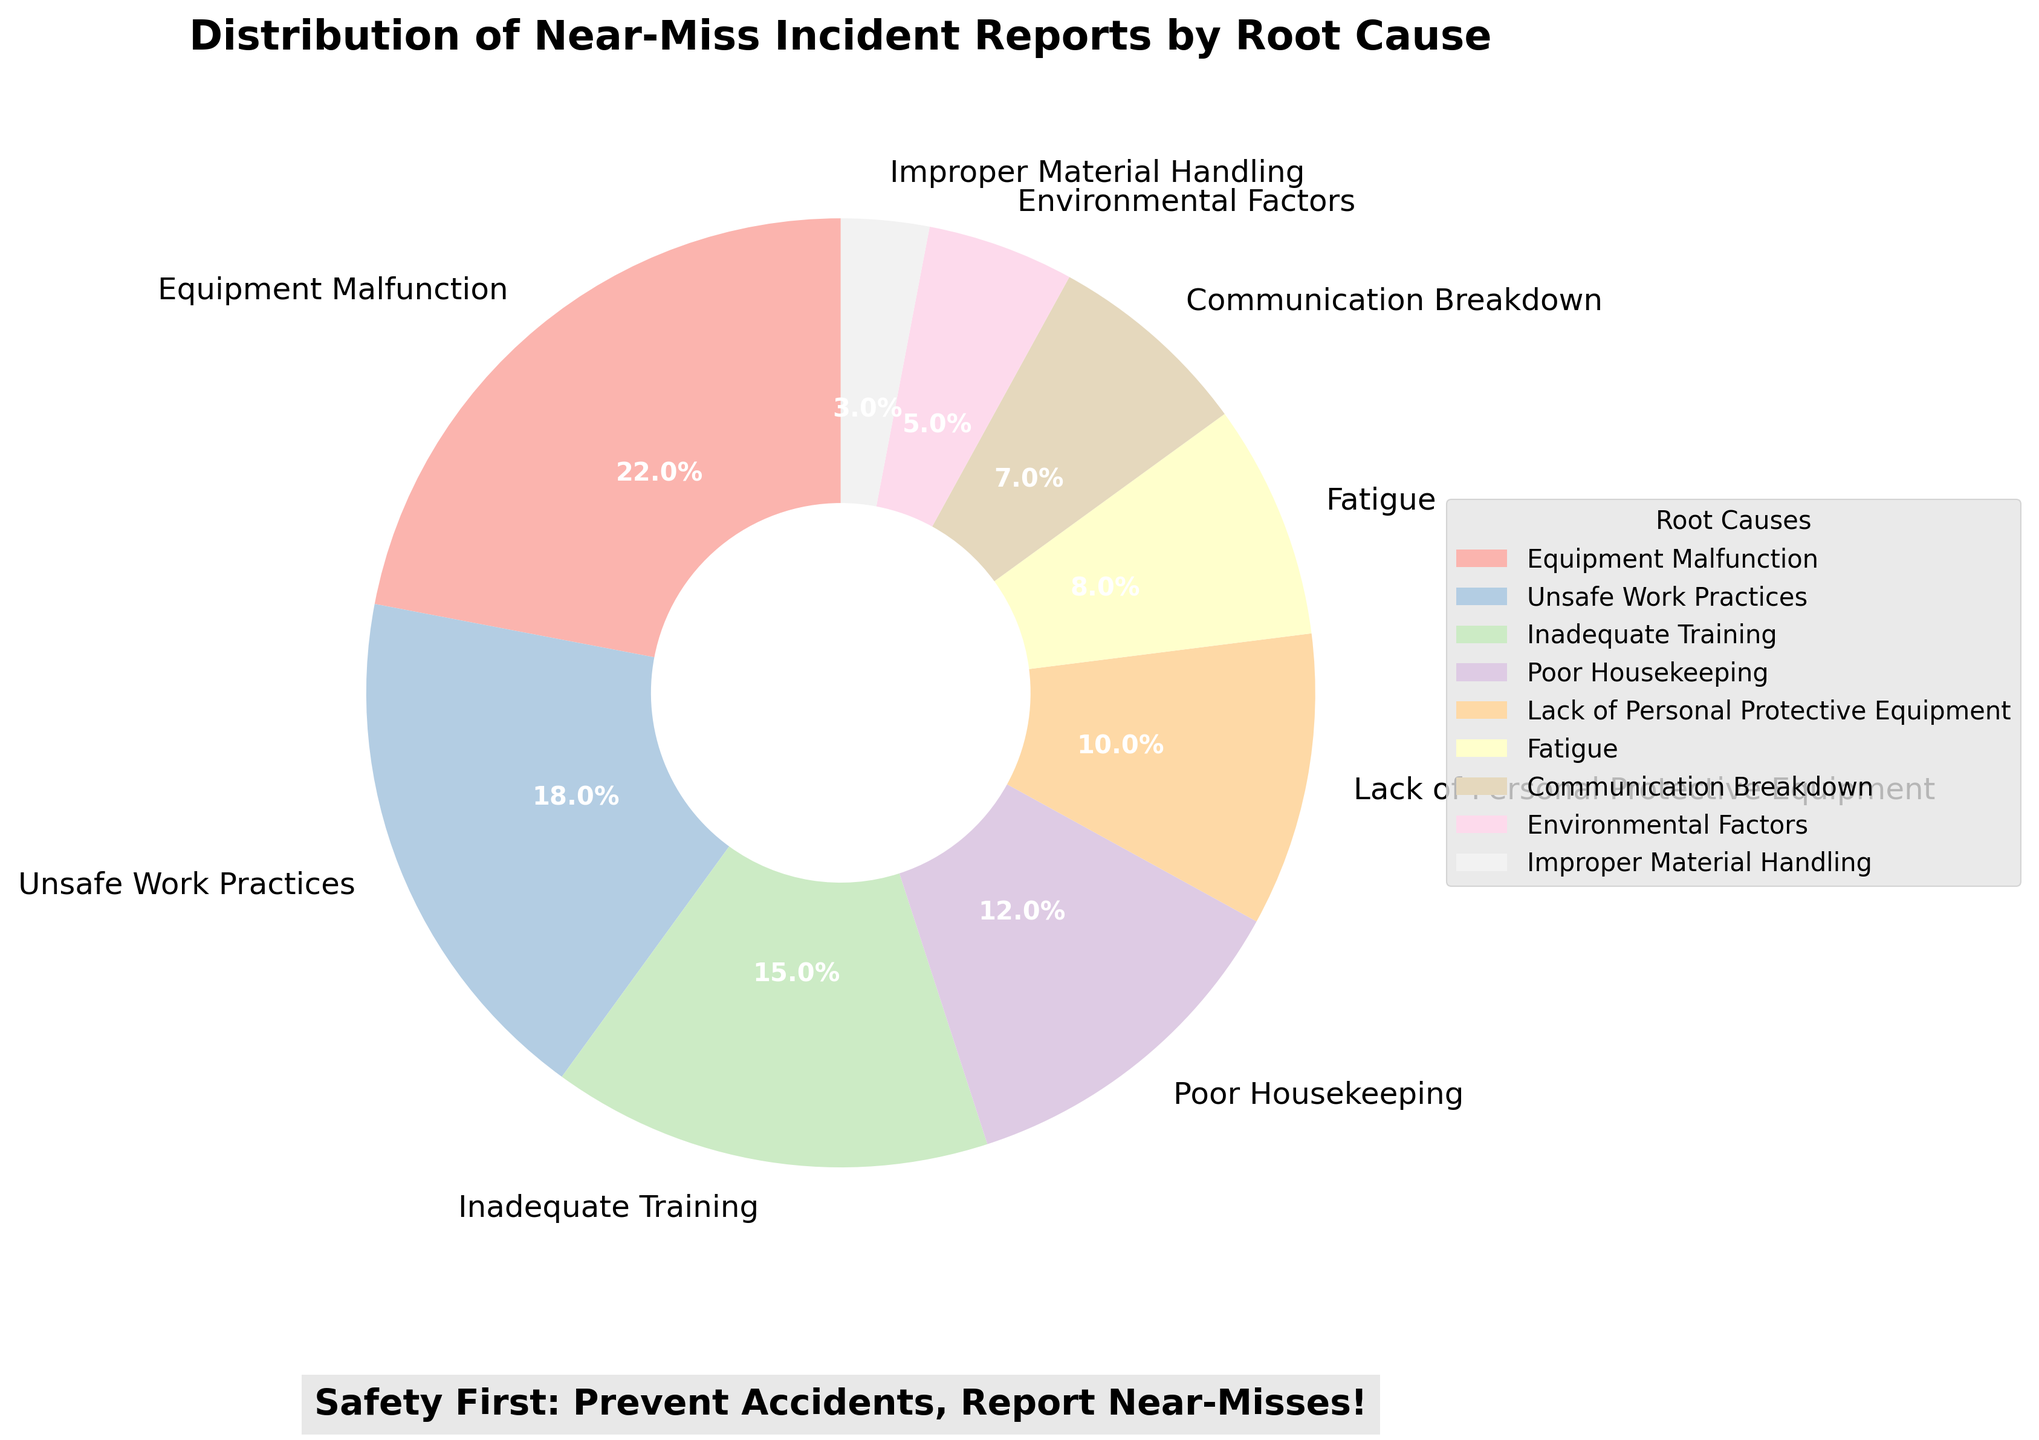What root cause has the highest percentage of near-miss incident reports? To find the root cause with the highest percentage, locate the segment in the pie chart with the largest area. The label associated with this segment indicates the root cause. In this case, it is "Equipment Malfunction" with 22%.
Answer: Equipment Malfunction Compare the combined percentage of "Inadequate Training" and "Poor Housekeeping" to "Unsafe Work Practices." Which is higher? First, sum the percentages of "Inadequate Training" (15%) and "Poor Housekeeping" (12%), resulting in 27%. Then compare this to the percentage of "Unsafe Work Practices" which is 18%. 27% is higher than 18%.
Answer: "Inadequate Training" and "Poor Housekeeping" What are the two root causes with the lowest percentages? Identify the two smallest segments in the pie chart. The segments for "Improper Material Handling" (3%) and "Environmental Factors" (5%) are the smallest.
Answer: Improper Material Handling and Environmental Factors How much of the total percentage do "Fatigue" and "Communication Breakdown" incidents account for together? Sum the percentages for "Fatigue" (8%) and "Communication Breakdown" (7%). 8% + 7% = 15%.
Answer: 15% Is the percentage of near-miss incidents due to "Lack of Personal Protective Equipment" greater than the percentage due to "Communication Breakdown"? Compare the percentages of "Lack of Personal Protective Equipment" (10%) and "Communication Breakdown" (7%). Since 10% is greater than 7%, the answer is yes.
Answer: Yes What percentage of incidents is attributed to "Environmental Factors" and "Improper Material Handling" combined? Add the percentages of "Environmental Factors" (5%) and "Improper Material Handling" (3%). 5% + 3% = 8%.
Answer: 8% How does the percentage of unsafe work practices compare to the lack of personal protective equipment? Compare the percentages of "Unsafe Work Practices" (18%) and "Lack of Personal Protective Equipment" (10%). 18% is higher than 10%.
Answer: Unsafe Work Practices is higher What is the total percentage of near-miss incidents caused by "Poor Housekeeping" and "Fatigue"? Add the percentages of "Poor Housekeeping" (12%) and "Fatigue" (8%). 12% + 8% = 20%.
Answer: 20% Which root cause accounts for 15% of the near-miss incident reports? Identify the segment of the pie chart with the label "15%". The label corresponding to this percentage is "Inadequate Training".
Answer: Inadequate Training 